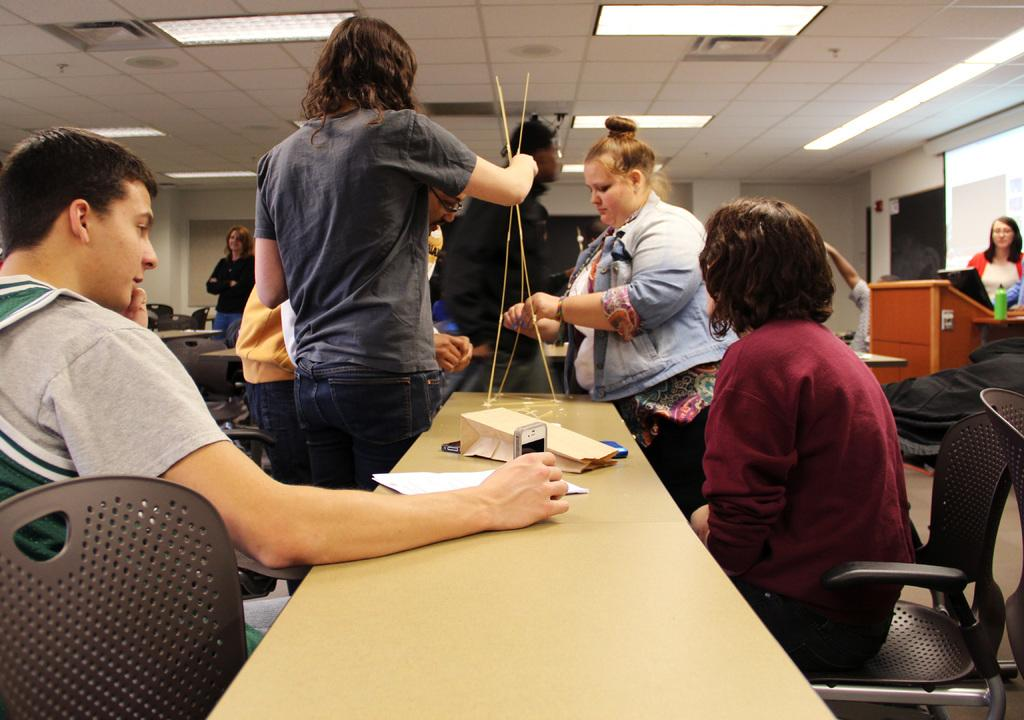What is the primary action of the person in the image? There is a person standing in the image. What are the other people in the image doing? There is a group of persons sitting in chairs. What is on the table in the image? There is a paper on the table. What can be seen in the background of the image? There is a screen, lights, and cupboards in the background. Can you see a ghost interacting with the paper on the table in the image? There is no ghost present in the image. What type of school is depicted in the image? The image does not depict a school; it shows a person standing, a group of persons sitting, a table with a paper, and a background with a screen, lights, and cupboards. 